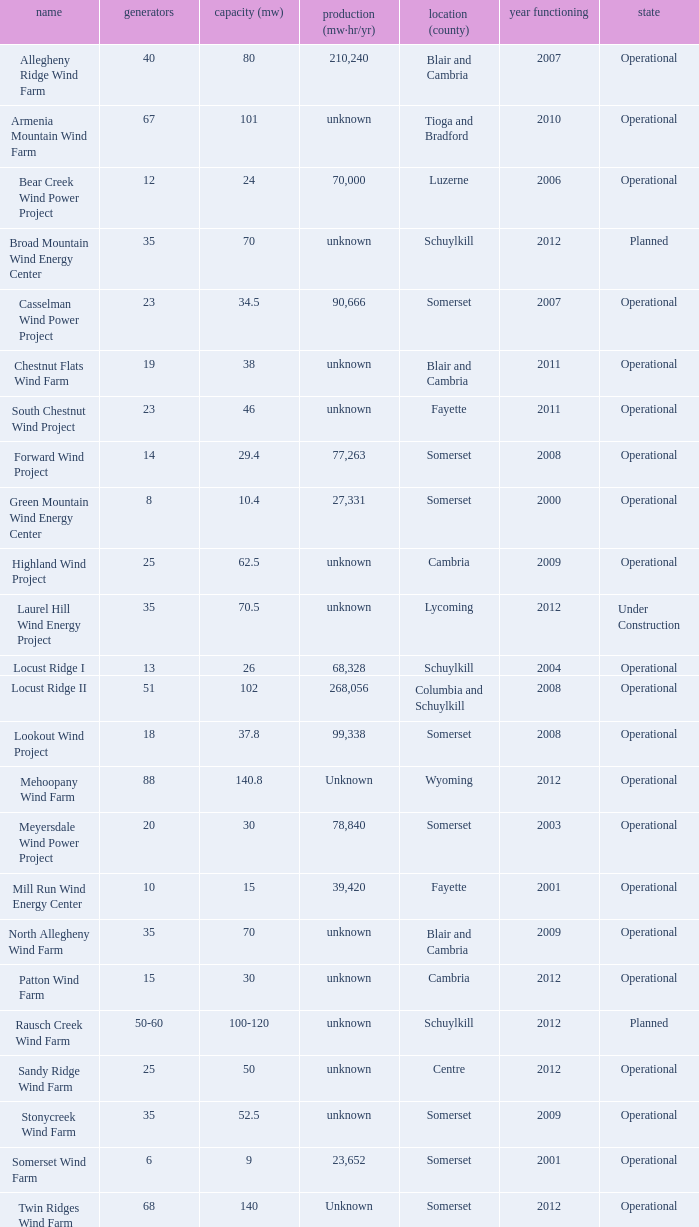What locations are considered centre? Unknown. 